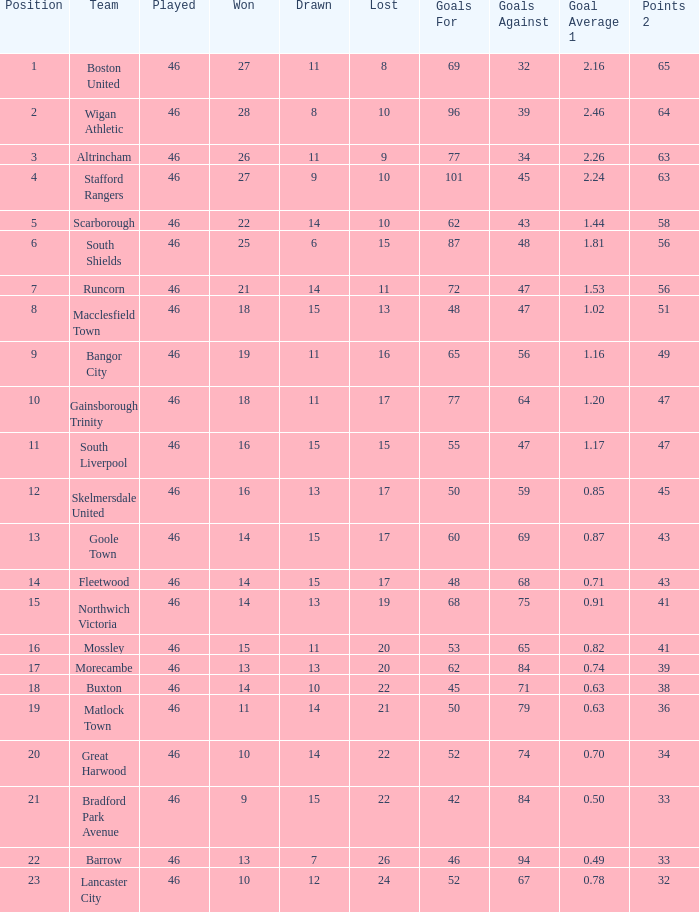How many points did Goole Town accumulate? 1.0. 